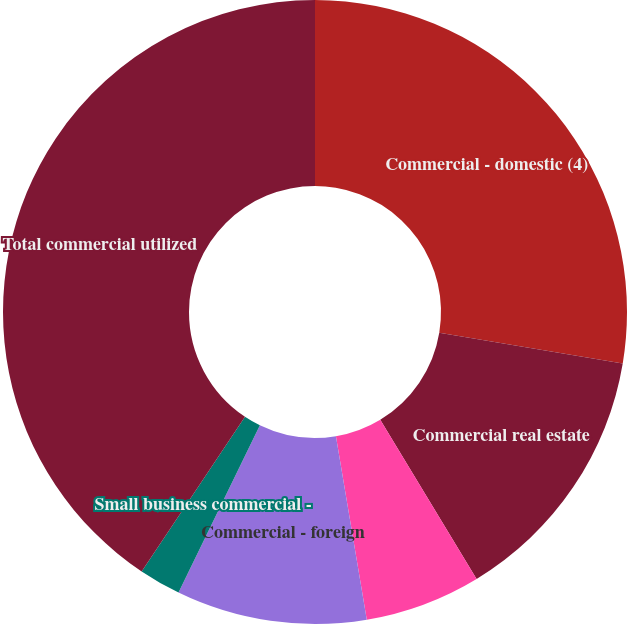Convert chart to OTSL. <chart><loc_0><loc_0><loc_500><loc_500><pie_chart><fcel>Commercial - domestic (4)<fcel>Commercial real estate<fcel>Commercial lease financing<fcel>Commercial - foreign<fcel>Small business commercial -<fcel>Total commercial utilized<nl><fcel>27.63%<fcel>13.7%<fcel>6.01%<fcel>9.86%<fcel>2.17%<fcel>40.62%<nl></chart> 